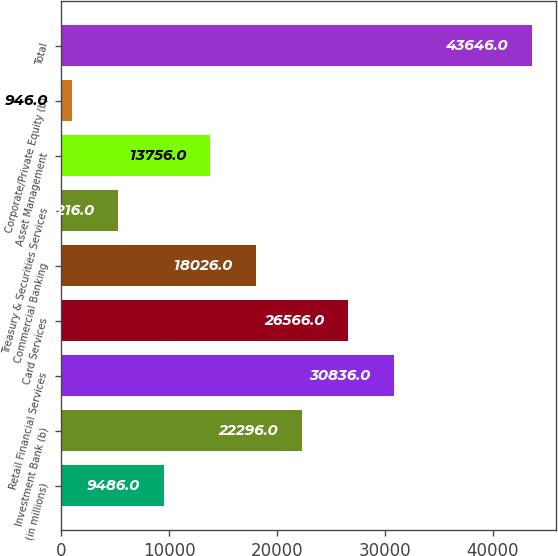Convert chart to OTSL. <chart><loc_0><loc_0><loc_500><loc_500><bar_chart><fcel>(in millions)<fcel>Investment Bank (b)<fcel>Retail Financial Services<fcel>Card Services<fcel>Commercial Banking<fcel>Treasury & Securities Services<fcel>Asset Management<fcel>Corporate/Private Equity (b)<fcel>Total<nl><fcel>9486<fcel>22296<fcel>30836<fcel>26566<fcel>18026<fcel>5216<fcel>13756<fcel>946<fcel>43646<nl></chart> 